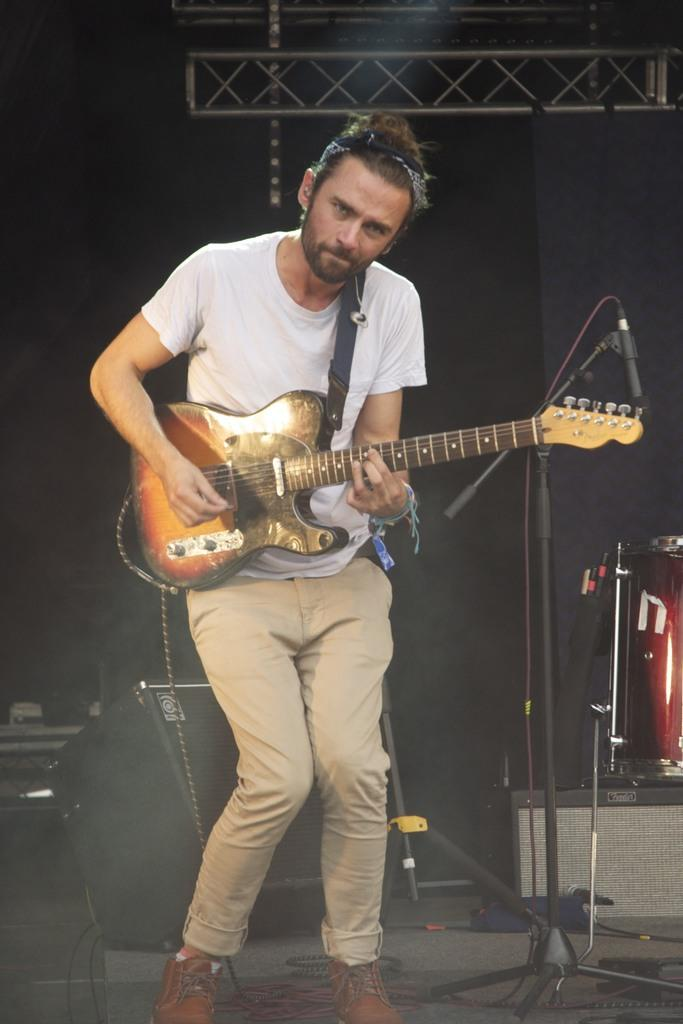What is the main subject of the image? There is a person in the image. What is the person wearing? The person is wearing a white t-shirt. What object is the person holding? The person is holding a guitar. What other item can be seen in the image? There is a speaker visible in the image. How many cubs are playing with the guitar in the image? There are no cubs present in the image, and the guitar is being held by the person. 